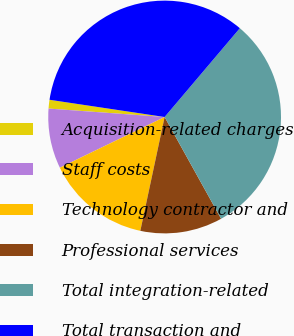Convert chart to OTSL. <chart><loc_0><loc_0><loc_500><loc_500><pie_chart><fcel>Acquisition-related charges<fcel>Staff costs<fcel>Technology contractor and<fcel>Professional services<fcel>Total integration-related<fcel>Total transaction and<nl><fcel>1.21%<fcel>8.33%<fcel>14.48%<fcel>11.41%<fcel>30.75%<fcel>33.82%<nl></chart> 